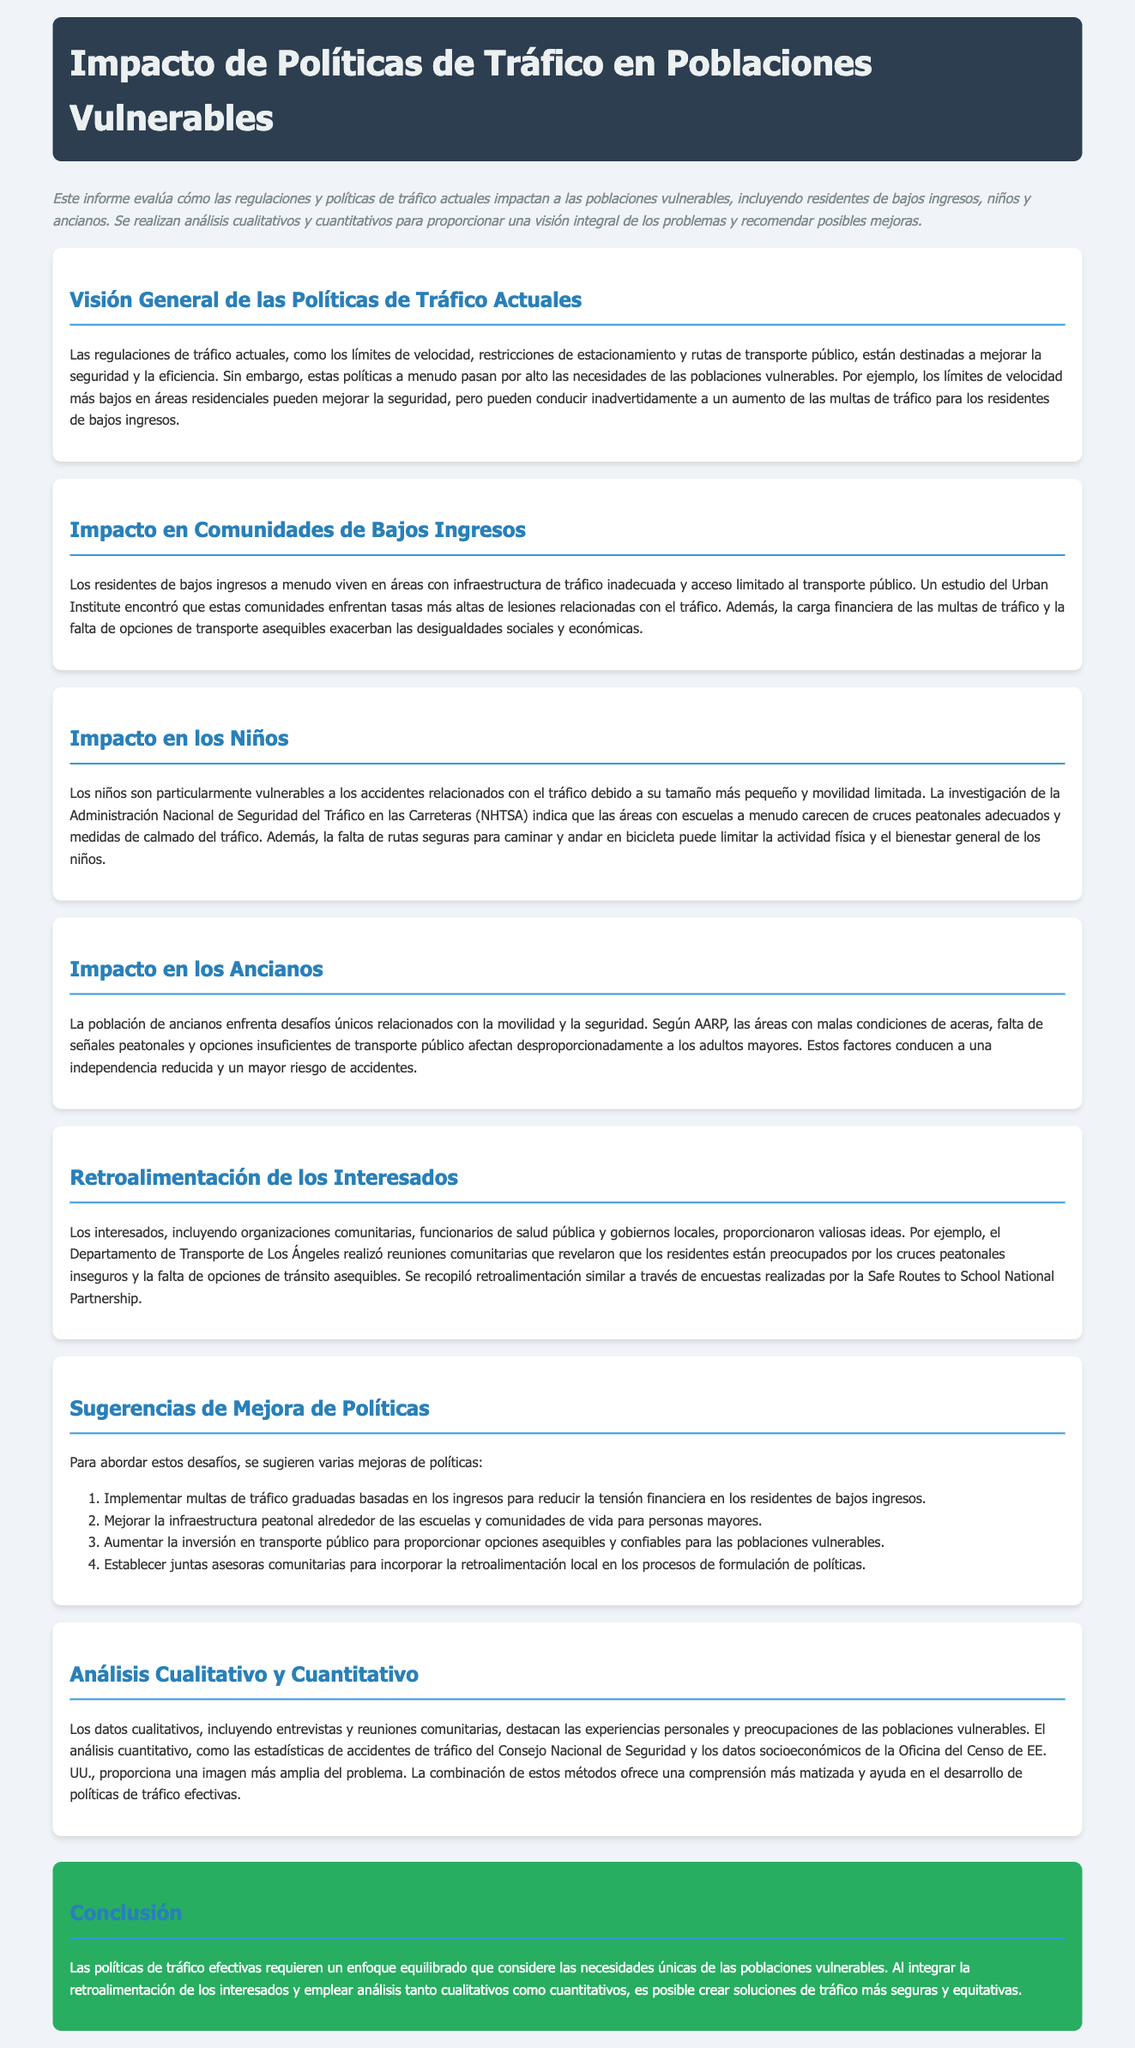¿Qué se evalúa en este informe? El informe evalúa cómo las regulaciones y políticas de tráfico actuales impactan a las poblaciones vulnerables.
Answer: Las regulaciones y políticas de tráfico actuales ¿Cuáles son las poblaciones vulnerables mencionadas? Las poblaciones vulnerables mencionadas son residentes de bajos ingresos, niños y ancianos.
Answer: Residentes de bajos ingresos, niños y ancianos ¿Qué efecto tienen los límites de velocidad más bajos en los residentes de bajos ingresos? Los límites de velocidad más bajos pueden conducir a un aumento de las multas de tráfico para los residentes de bajos ingresos.
Answer: Aumento de las multas de tráfico ¿Qué hallazgo se menciona en relación con la infraestructura de tráfico en comunidades de bajos ingresos? Se menciona que estas comunidades enfrentan tasas más altas de lesiones relacionadas con el tráfico.
Answer: Tasas más altas de lesiones relacionadas con el tráfico ¿Qué sugiere el informe para mejorar la infraestructura peatonal? Se sugiere mejorar la infraestructura peatonal alrededor de las escuelas y comunidades de vida para personas mayores.
Answer: Mejorar infraestructura peatonal ¿Cuál es un resultado de la falta de opciones de transporte público para ancianos? La falta de opciones de transporte público conduce a una independencia reducida para los ancianos.
Answer: Independencia reducida ¿Qué método se utiliza para combinar datos en el análisis? Se combinan análisis cualitativos y cuantitativos para ofrecer una comprensión más matizada.
Answer: Análisis cualitativos y cuantitativos ¿Qué tipo de reuniones realizaron los funcionarios del Departamento de Transporte de Los Ángeles? Realizaron reuniones comunitarias para obtener retroalimentación sobre la seguridad de los cruces peatonales.
Answer: Reuniones comunitarias ¿Cuál es una de las sugerencias para reducir la carga financiera de las multas? Implementar multas de tráfico graduadas basadas en los ingresos.
Answer: Multas de tráfico graduadas 